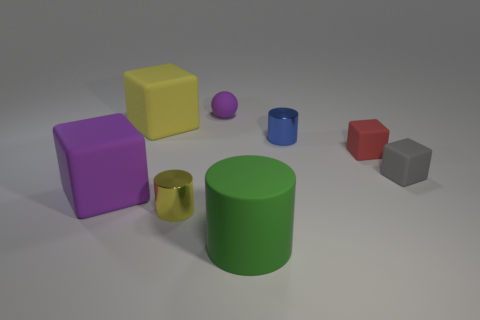Add 2 yellow rubber spheres. How many objects exist? 10 Subtract all cylinders. How many objects are left? 5 Add 6 tiny gray rubber cubes. How many tiny gray rubber cubes are left? 7 Add 7 tiny purple objects. How many tiny purple objects exist? 8 Subtract 1 yellow blocks. How many objects are left? 7 Subtract all small yellow matte blocks. Subtract all gray matte blocks. How many objects are left? 7 